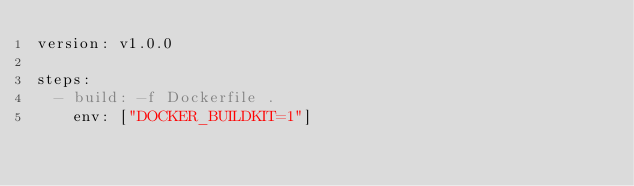Convert code to text. <code><loc_0><loc_0><loc_500><loc_500><_YAML_>version: v1.0.0

steps:
  - build: -f Dockerfile .
    env: ["DOCKER_BUILDKIT=1"]</code> 